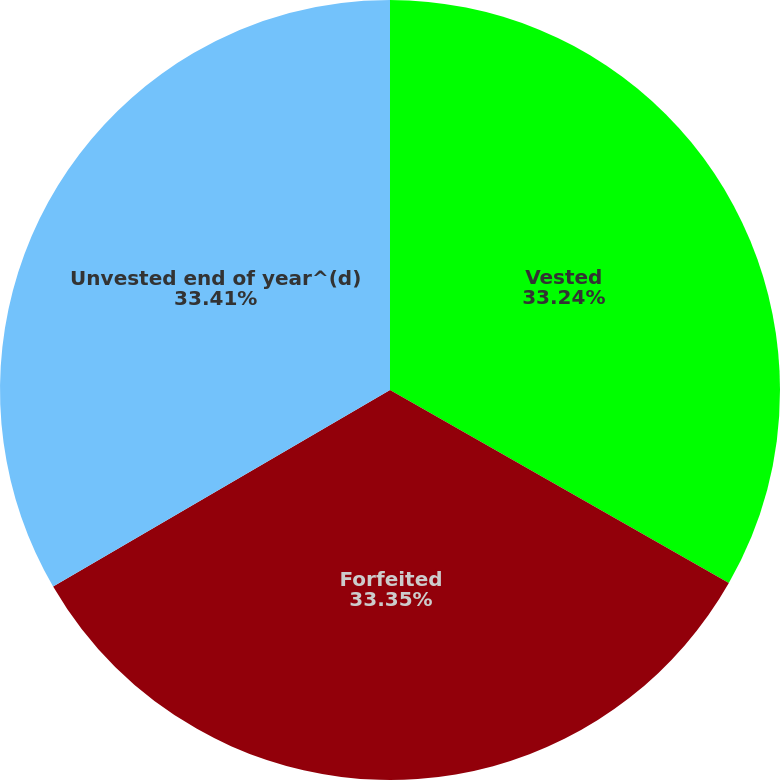Convert chart to OTSL. <chart><loc_0><loc_0><loc_500><loc_500><pie_chart><fcel>Vested<fcel>Forfeited<fcel>Unvested end of year^(d)<nl><fcel>33.24%<fcel>33.35%<fcel>33.4%<nl></chart> 